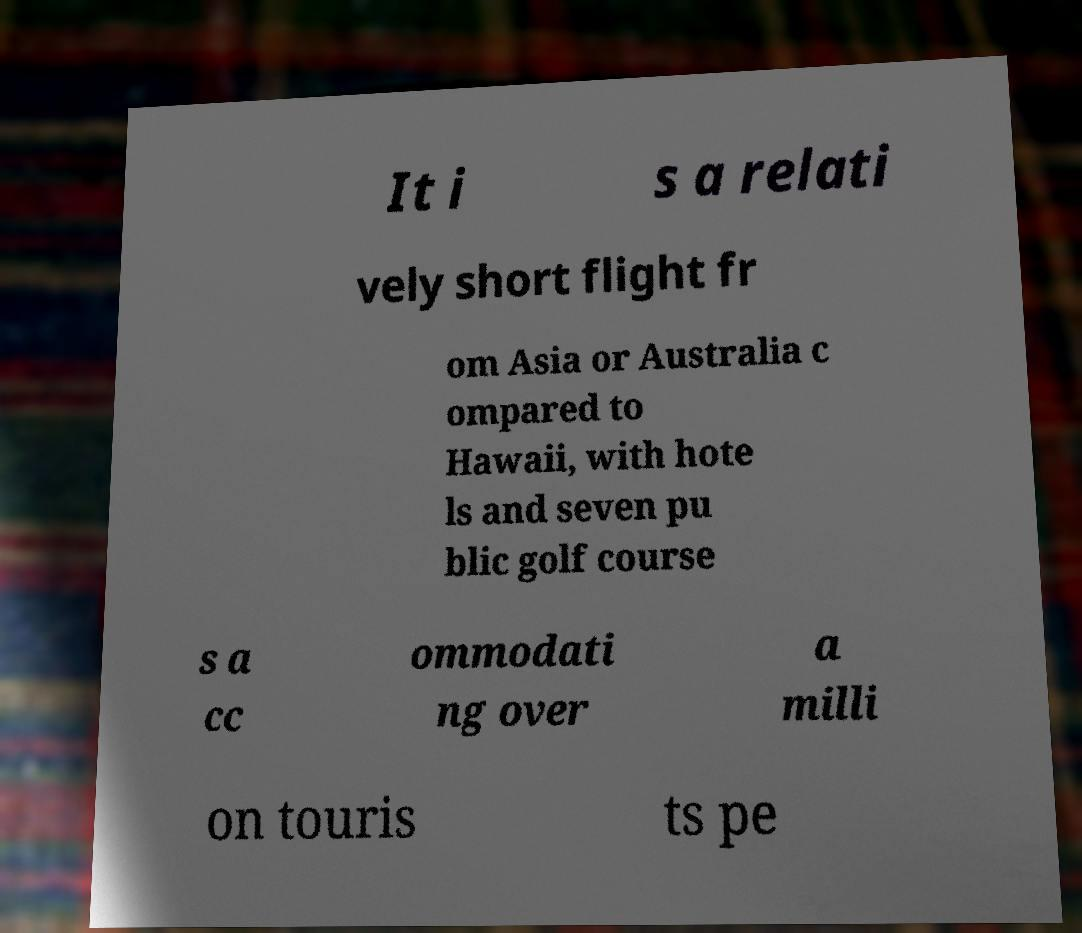I need the written content from this picture converted into text. Can you do that? It i s a relati vely short flight fr om Asia or Australia c ompared to Hawaii, with hote ls and seven pu blic golf course s a cc ommodati ng over a milli on touris ts pe 